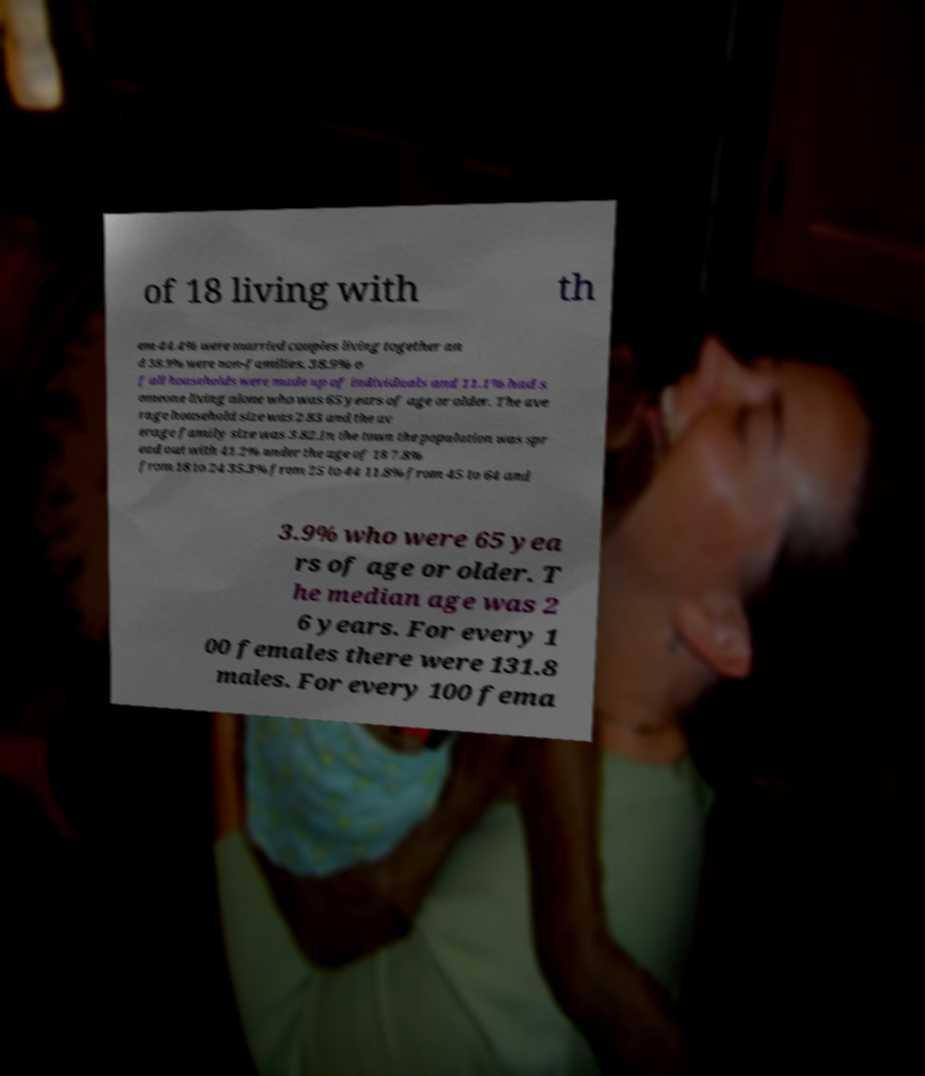For documentation purposes, I need the text within this image transcribed. Could you provide that? of 18 living with th em 44.4% were married couples living together an d 38.9% were non-families. 38.9% o f all households were made up of individuals and 11.1% had s omeone living alone who was 65 years of age or older. The ave rage household size was 2.83 and the av erage family size was 3.82.In the town the population was spr ead out with 41.2% under the age of 18 7.8% from 18 to 24 35.3% from 25 to 44 11.8% from 45 to 64 and 3.9% who were 65 yea rs of age or older. T he median age was 2 6 years. For every 1 00 females there were 131.8 males. For every 100 fema 